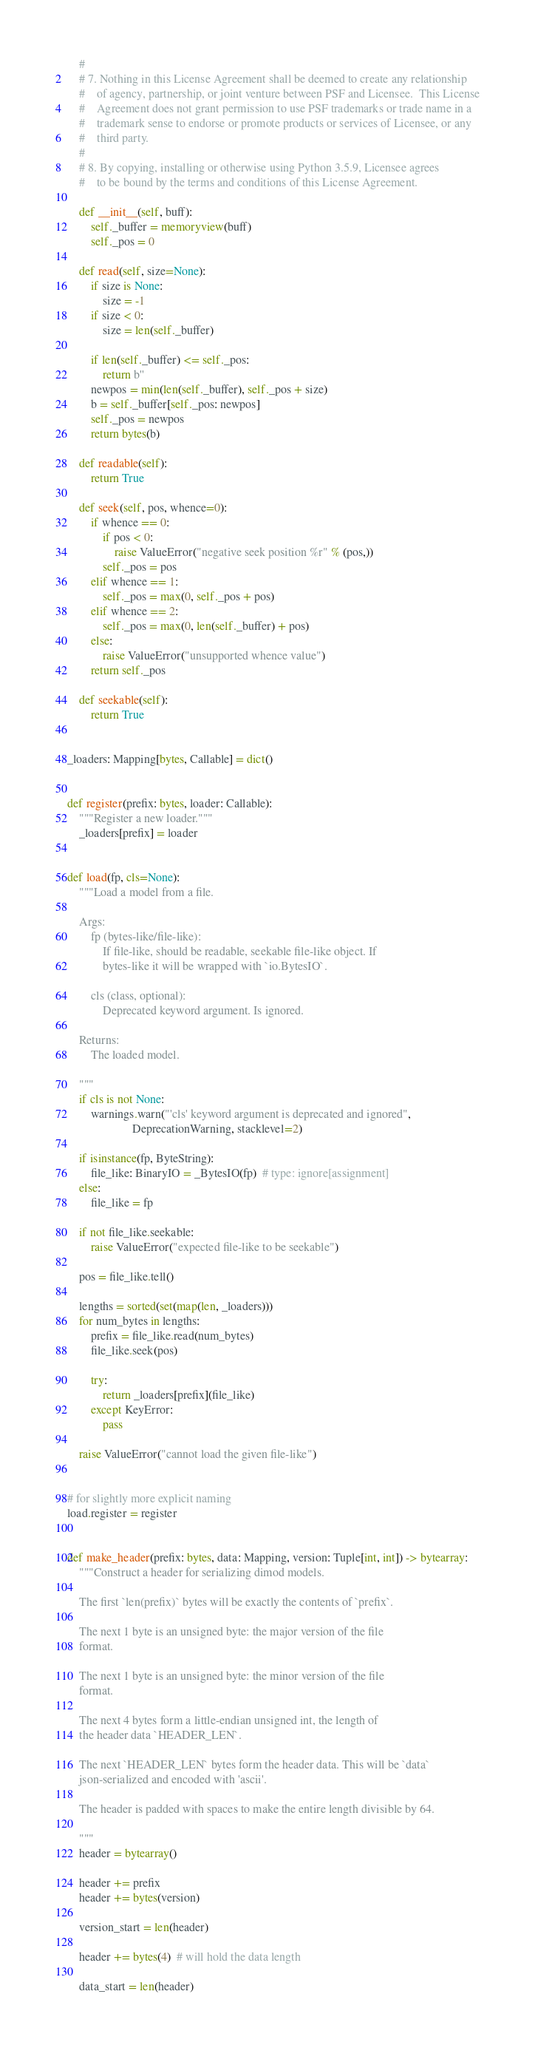Convert code to text. <code><loc_0><loc_0><loc_500><loc_500><_Python_>    #
    # 7. Nothing in this License Agreement shall be deemed to create any relationship
    #    of agency, partnership, or joint venture between PSF and Licensee.  This License
    #    Agreement does not grant permission to use PSF trademarks or trade name in a
    #    trademark sense to endorse or promote products or services of Licensee, or any
    #    third party.
    #
    # 8. By copying, installing or otherwise using Python 3.5.9, Licensee agrees
    #    to be bound by the terms and conditions of this License Agreement.

    def __init__(self, buff):
        self._buffer = memoryview(buff)
        self._pos = 0

    def read(self, size=None):
        if size is None:
            size = -1
        if size < 0:
            size = len(self._buffer)

        if len(self._buffer) <= self._pos:
            return b''
        newpos = min(len(self._buffer), self._pos + size)
        b = self._buffer[self._pos: newpos]
        self._pos = newpos
        return bytes(b)

    def readable(self):
        return True

    def seek(self, pos, whence=0):
        if whence == 0:
            if pos < 0:
                raise ValueError("negative seek position %r" % (pos,))
            self._pos = pos
        elif whence == 1:
            self._pos = max(0, self._pos + pos)
        elif whence == 2:
            self._pos = max(0, len(self._buffer) + pos)
        else:
            raise ValueError("unsupported whence value")
        return self._pos

    def seekable(self):
        return True


_loaders: Mapping[bytes, Callable] = dict()


def register(prefix: bytes, loader: Callable):
    """Register a new loader."""
    _loaders[prefix] = loader


def load(fp, cls=None):
    """Load a model from a file.

    Args:
        fp (bytes-like/file-like):
            If file-like, should be readable, seekable file-like object. If
            bytes-like it will be wrapped with `io.BytesIO`.

        cls (class, optional):
            Deprecated keyword argument. Is ignored.

    Returns:
        The loaded model.

    """
    if cls is not None:
        warnings.warn("'cls' keyword argument is deprecated and ignored",
                      DeprecationWarning, stacklevel=2)

    if isinstance(fp, ByteString):
        file_like: BinaryIO = _BytesIO(fp)  # type: ignore[assignment]
    else:
        file_like = fp

    if not file_like.seekable:
        raise ValueError("expected file-like to be seekable")

    pos = file_like.tell()

    lengths = sorted(set(map(len, _loaders)))
    for num_bytes in lengths:
        prefix = file_like.read(num_bytes)
        file_like.seek(pos)

        try:
            return _loaders[prefix](file_like)
        except KeyError:
            pass

    raise ValueError("cannot load the given file-like")


# for slightly more explicit naming
load.register = register


def make_header(prefix: bytes, data: Mapping, version: Tuple[int, int]) -> bytearray:
    """Construct a header for serializing dimod models.

    The first `len(prefix)` bytes will be exactly the contents of `prefix`.

    The next 1 byte is an unsigned byte: the major version of the file
    format.

    The next 1 byte is an unsigned byte: the minor version of the file
    format.

    The next 4 bytes form a little-endian unsigned int, the length of
    the header data `HEADER_LEN`.

    The next `HEADER_LEN` bytes form the header data. This will be `data`
    json-serialized and encoded with 'ascii'.

    The header is padded with spaces to make the entire length divisible by 64.

    """
    header = bytearray()

    header += prefix
    header += bytes(version)

    version_start = len(header)

    header += bytes(4)  # will hold the data length

    data_start = len(header)
</code> 